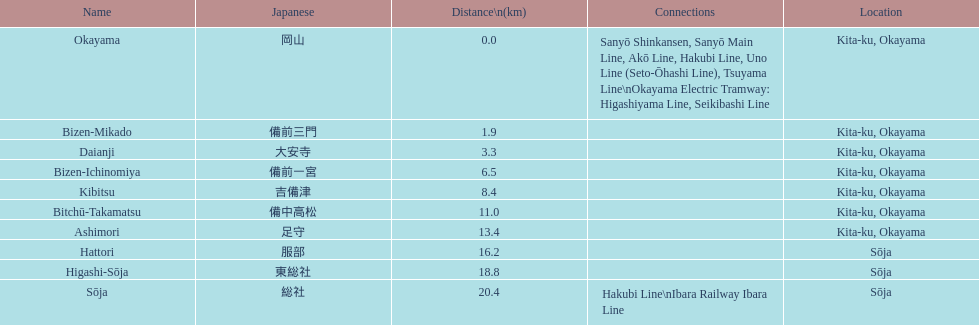What is the count of stations present in kita-ku, okayama? 7. 